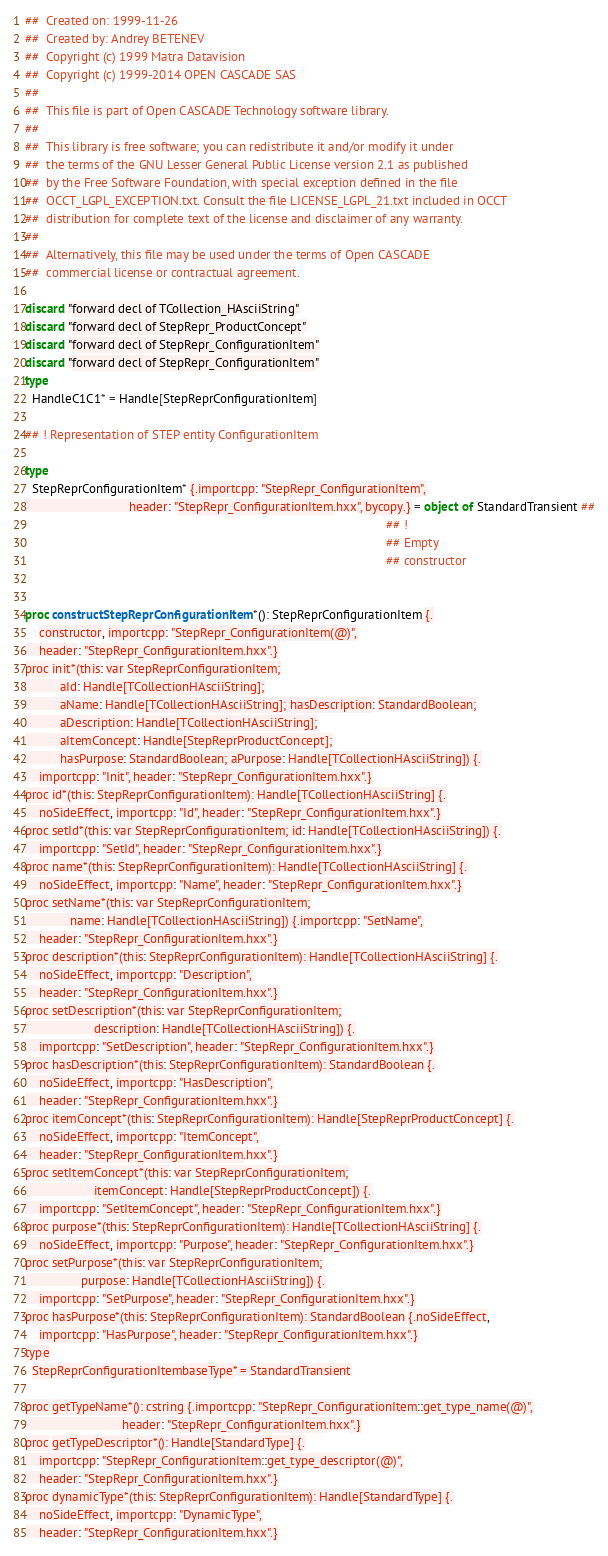Convert code to text. <code><loc_0><loc_0><loc_500><loc_500><_Nim_>##  Created on: 1999-11-26
##  Created by: Andrey BETENEV
##  Copyright (c) 1999 Matra Datavision
##  Copyright (c) 1999-2014 OPEN CASCADE SAS
##
##  This file is part of Open CASCADE Technology software library.
##
##  This library is free software; you can redistribute it and/or modify it under
##  the terms of the GNU Lesser General Public License version 2.1 as published
##  by the Free Software Foundation, with special exception defined in the file
##  OCCT_LGPL_EXCEPTION.txt. Consult the file LICENSE_LGPL_21.txt included in OCCT
##  distribution for complete text of the license and disclaimer of any warranty.
##
##  Alternatively, this file may be used under the terms of Open CASCADE
##  commercial license or contractual agreement.

discard "forward decl of TCollection_HAsciiString"
discard "forward decl of StepRepr_ProductConcept"
discard "forward decl of StepRepr_ConfigurationItem"
discard "forward decl of StepRepr_ConfigurationItem"
type
  HandleC1C1* = Handle[StepReprConfigurationItem]

## ! Representation of STEP entity ConfigurationItem

type
  StepReprConfigurationItem* {.importcpp: "StepRepr_ConfigurationItem",
                              header: "StepRepr_ConfigurationItem.hxx", bycopy.} = object of StandardTransient ##
                                                                                                        ## !
                                                                                                        ## Empty
                                                                                                        ## constructor


proc constructStepReprConfigurationItem*(): StepReprConfigurationItem {.
    constructor, importcpp: "StepRepr_ConfigurationItem(@)",
    header: "StepRepr_ConfigurationItem.hxx".}
proc init*(this: var StepReprConfigurationItem;
          aId: Handle[TCollectionHAsciiString];
          aName: Handle[TCollectionHAsciiString]; hasDescription: StandardBoolean;
          aDescription: Handle[TCollectionHAsciiString];
          aItemConcept: Handle[StepReprProductConcept];
          hasPurpose: StandardBoolean; aPurpose: Handle[TCollectionHAsciiString]) {.
    importcpp: "Init", header: "StepRepr_ConfigurationItem.hxx".}
proc id*(this: StepReprConfigurationItem): Handle[TCollectionHAsciiString] {.
    noSideEffect, importcpp: "Id", header: "StepRepr_ConfigurationItem.hxx".}
proc setId*(this: var StepReprConfigurationItem; id: Handle[TCollectionHAsciiString]) {.
    importcpp: "SetId", header: "StepRepr_ConfigurationItem.hxx".}
proc name*(this: StepReprConfigurationItem): Handle[TCollectionHAsciiString] {.
    noSideEffect, importcpp: "Name", header: "StepRepr_ConfigurationItem.hxx".}
proc setName*(this: var StepReprConfigurationItem;
             name: Handle[TCollectionHAsciiString]) {.importcpp: "SetName",
    header: "StepRepr_ConfigurationItem.hxx".}
proc description*(this: StepReprConfigurationItem): Handle[TCollectionHAsciiString] {.
    noSideEffect, importcpp: "Description",
    header: "StepRepr_ConfigurationItem.hxx".}
proc setDescription*(this: var StepReprConfigurationItem;
                    description: Handle[TCollectionHAsciiString]) {.
    importcpp: "SetDescription", header: "StepRepr_ConfigurationItem.hxx".}
proc hasDescription*(this: StepReprConfigurationItem): StandardBoolean {.
    noSideEffect, importcpp: "HasDescription",
    header: "StepRepr_ConfigurationItem.hxx".}
proc itemConcept*(this: StepReprConfigurationItem): Handle[StepReprProductConcept] {.
    noSideEffect, importcpp: "ItemConcept",
    header: "StepRepr_ConfigurationItem.hxx".}
proc setItemConcept*(this: var StepReprConfigurationItem;
                    itemConcept: Handle[StepReprProductConcept]) {.
    importcpp: "SetItemConcept", header: "StepRepr_ConfigurationItem.hxx".}
proc purpose*(this: StepReprConfigurationItem): Handle[TCollectionHAsciiString] {.
    noSideEffect, importcpp: "Purpose", header: "StepRepr_ConfigurationItem.hxx".}
proc setPurpose*(this: var StepReprConfigurationItem;
                purpose: Handle[TCollectionHAsciiString]) {.
    importcpp: "SetPurpose", header: "StepRepr_ConfigurationItem.hxx".}
proc hasPurpose*(this: StepReprConfigurationItem): StandardBoolean {.noSideEffect,
    importcpp: "HasPurpose", header: "StepRepr_ConfigurationItem.hxx".}
type
  StepReprConfigurationItembaseType* = StandardTransient

proc getTypeName*(): cstring {.importcpp: "StepRepr_ConfigurationItem::get_type_name(@)",
                            header: "StepRepr_ConfigurationItem.hxx".}
proc getTypeDescriptor*(): Handle[StandardType] {.
    importcpp: "StepRepr_ConfigurationItem::get_type_descriptor(@)",
    header: "StepRepr_ConfigurationItem.hxx".}
proc dynamicType*(this: StepReprConfigurationItem): Handle[StandardType] {.
    noSideEffect, importcpp: "DynamicType",
    header: "StepRepr_ConfigurationItem.hxx".}</code> 